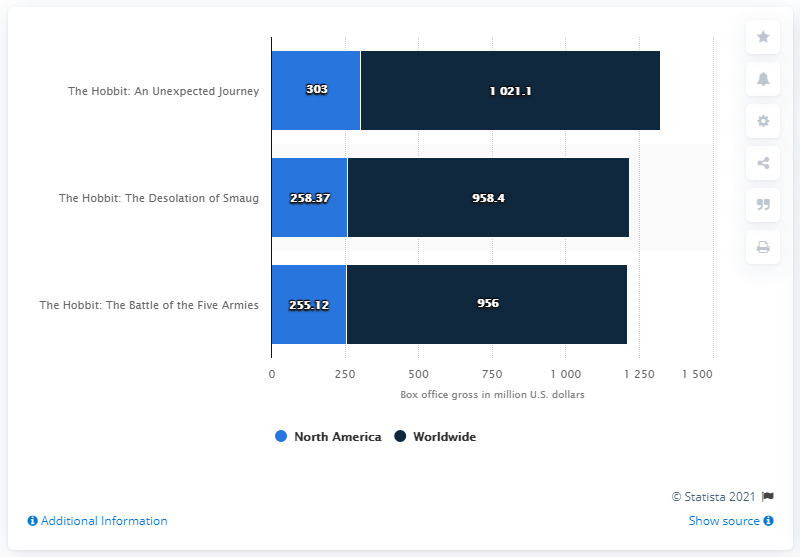Draw attention to some important aspects in this diagram. The North American revenue for the movie "The Hobbit: An Unexpected Journey" was 303 million U.S. dollars. The gross of The Hobbit: The Desolation of Smaug was 258.37 million dollars. The second installment in the trilogy was titled The Hobbit: The Desolation of Smaug. The total revenue for the movie "The Hobbit - The Battle of the Five Armies" is approximately 1211.12. 